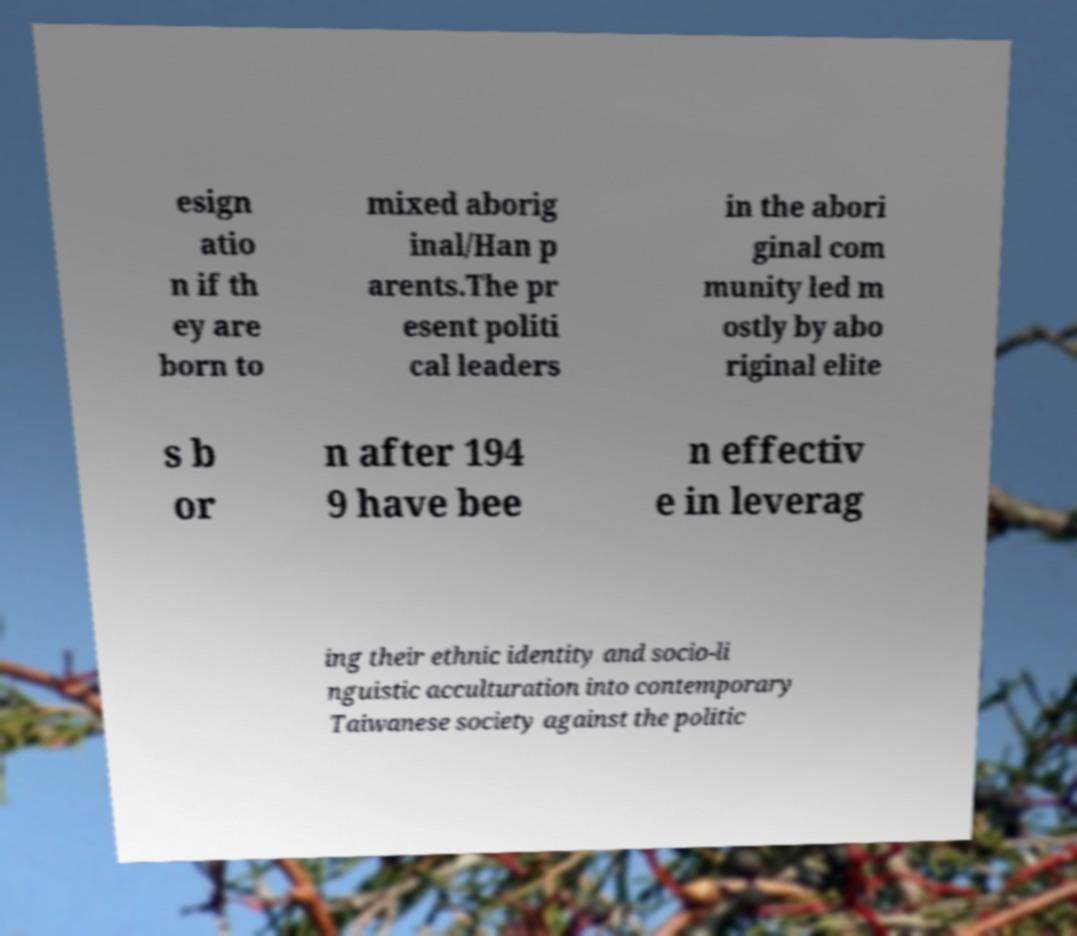Please read and relay the text visible in this image. What does it say? esign atio n if th ey are born to mixed aborig inal/Han p arents.The pr esent politi cal leaders in the abori ginal com munity led m ostly by abo riginal elite s b or n after 194 9 have bee n effectiv e in leverag ing their ethnic identity and socio-li nguistic acculturation into contemporary Taiwanese society against the politic 